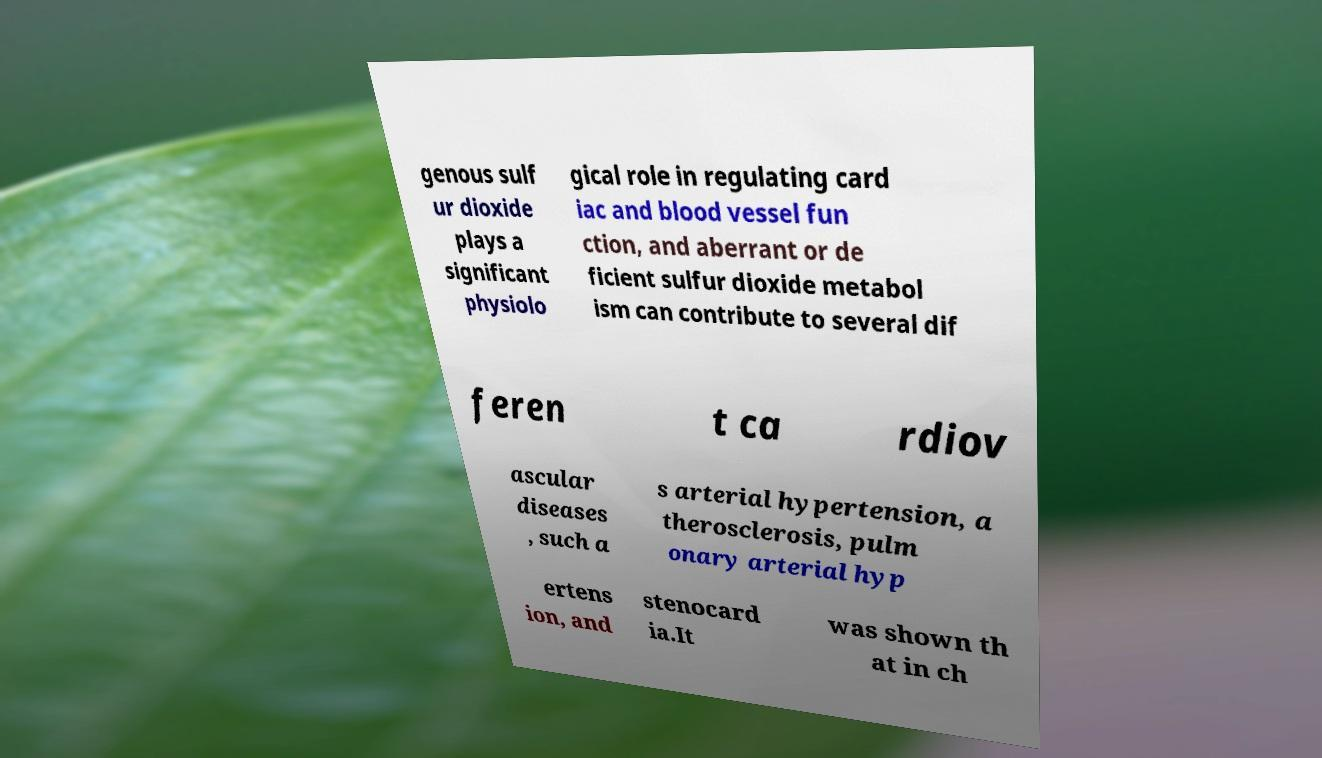Can you read and provide the text displayed in the image?This photo seems to have some interesting text. Can you extract and type it out for me? genous sulf ur dioxide plays a significant physiolo gical role in regulating card iac and blood vessel fun ction, and aberrant or de ficient sulfur dioxide metabol ism can contribute to several dif feren t ca rdiov ascular diseases , such a s arterial hypertension, a therosclerosis, pulm onary arterial hyp ertens ion, and stenocard ia.It was shown th at in ch 